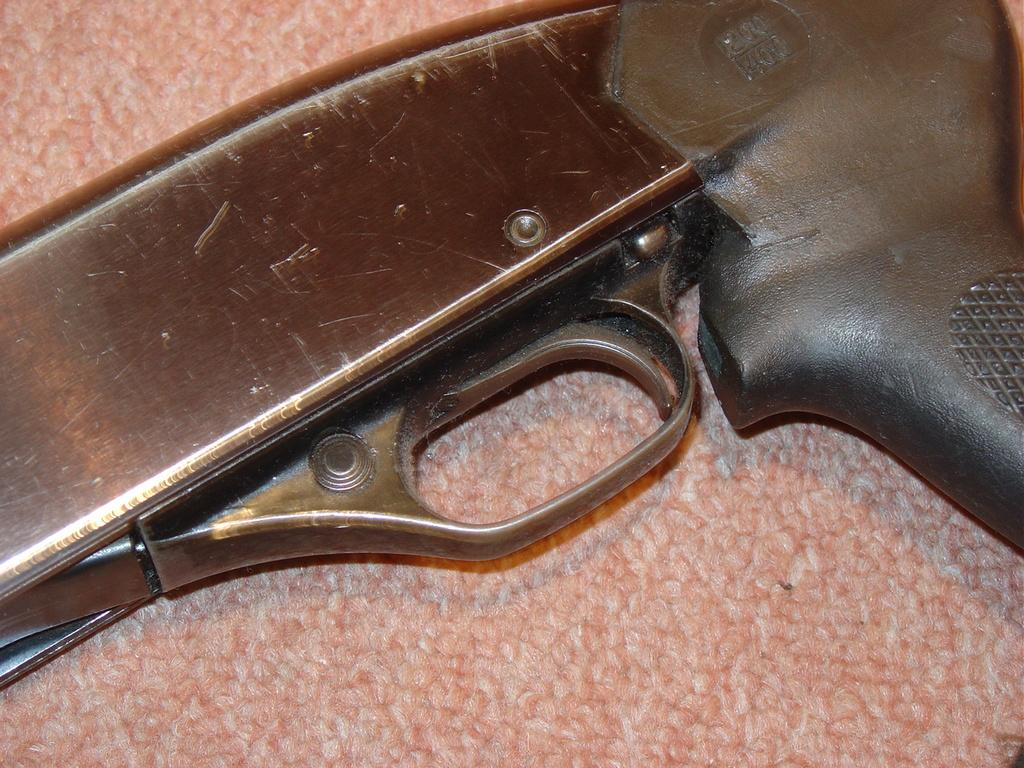What is the main object in the image? There is a weapon in the image. Can you describe the position of the weapon? The weapon is on an object. What type of prose is being written on the weapon in the image? There is no prose or writing present on the weapon in the image. 